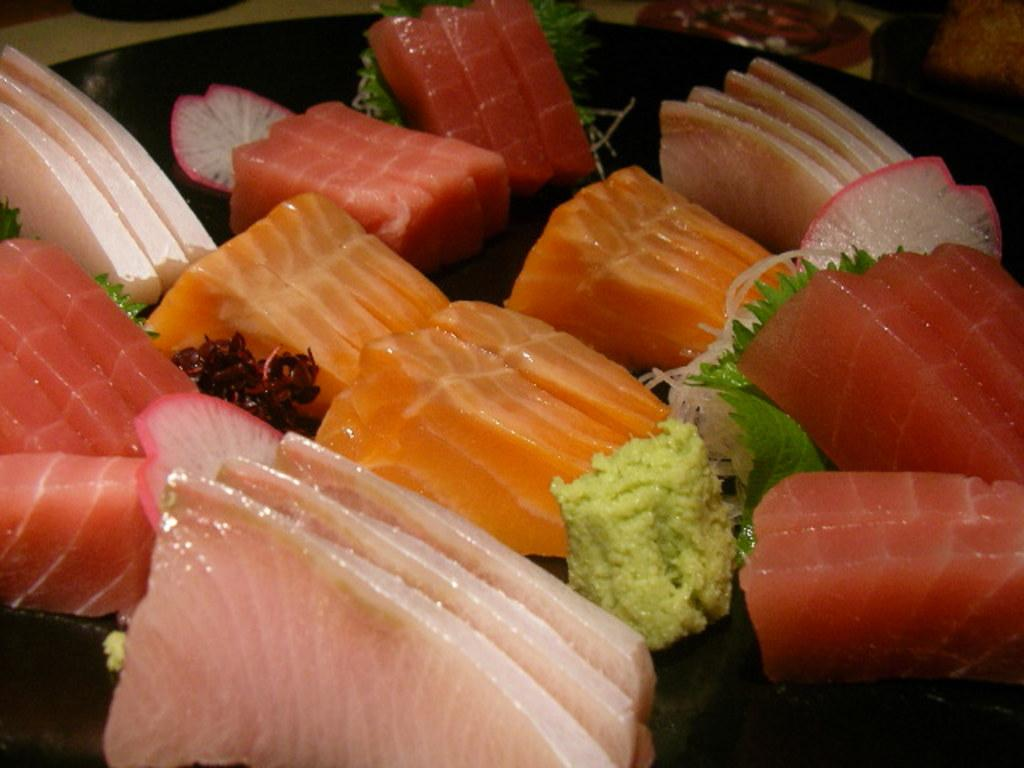What type of food can be seen in the image? There is meat in the image. How is the meat presented? The meat is served on a plate. Is the meat the only food item in the image? No, there are other food items in the image. Can you see any mice running around the plate of meat in the image? No, there are no mice present in the image. 